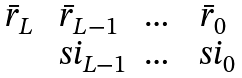Convert formula to latex. <formula><loc_0><loc_0><loc_500><loc_500>\begin{matrix} \bar { r } _ { L } & \bar { r } _ { L - 1 } & \dots & \bar { r } _ { 0 } \\ & \ s i _ { L - 1 } & \dots & \ s i _ { 0 } \end{matrix}</formula> 